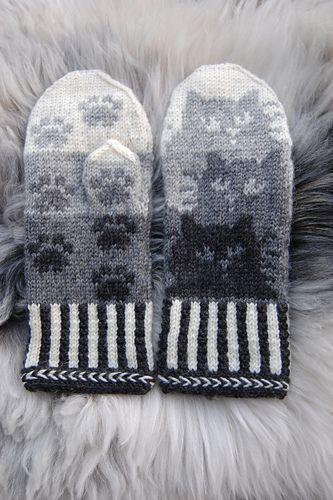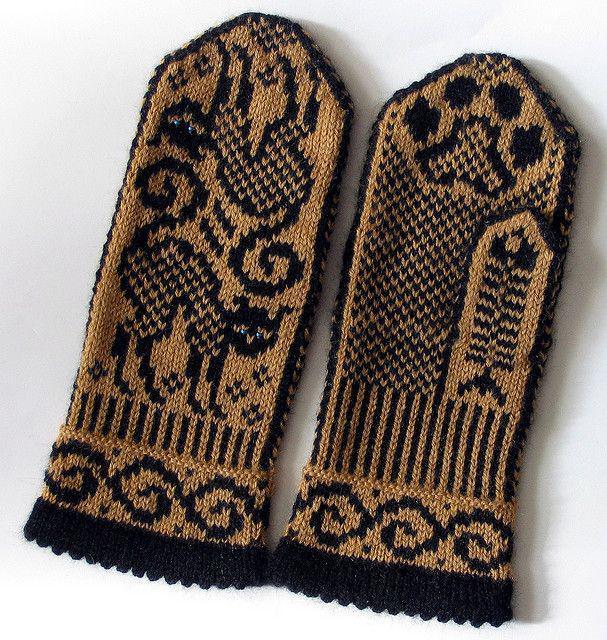The first image is the image on the left, the second image is the image on the right. Analyze the images presented: Is the assertion "In 1 of the images, 2 gloves have thumbs pointing inward." valid? Answer yes or no. No. 